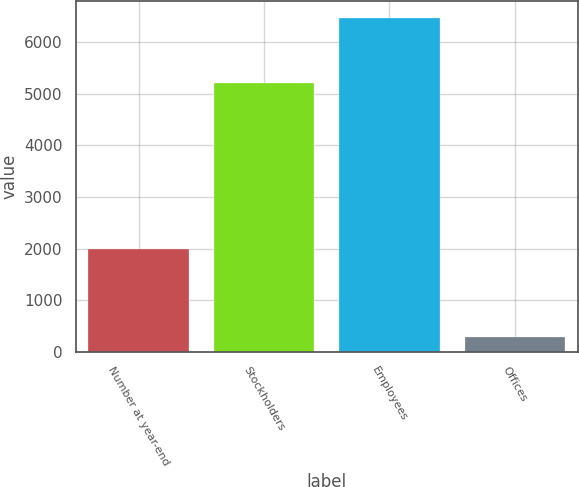Convert chart. <chart><loc_0><loc_0><loc_500><loc_500><bar_chart><fcel>Number at year-end<fcel>Stockholders<fcel>Employees<fcel>Offices<nl><fcel>1998<fcel>5207<fcel>6467<fcel>283<nl></chart> 